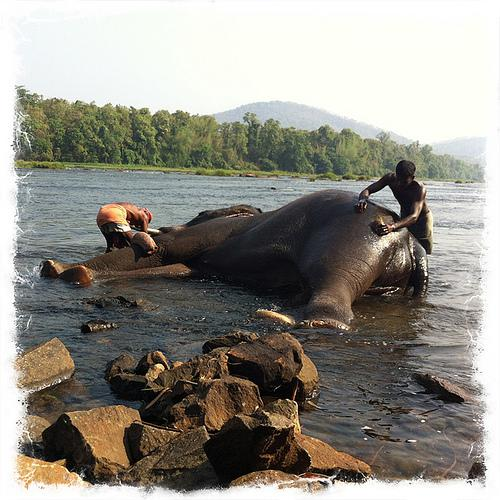Question: why is it so bright?
Choices:
A. Chandelier.
B. Fire.
C. Lightbulbs.
D. Sunlight.
Answer with the letter. Answer: D Question: what is the elephant doing?
Choices:
A. Sleeping.
B. Eating.
C. Washing itself.
D. Laying down.
Answer with the letter. Answer: D Question: what are the men doing?
Choices:
A. Feeding the animal.
B. Cleaning an animal.
C. Watching the animal.
D. Catching the animal.
Answer with the letter. Answer: B Question: what color is the water?
Choices:
A. Blue.
B. Clear.
C. Brown.
D. White.
Answer with the letter. Answer: C 